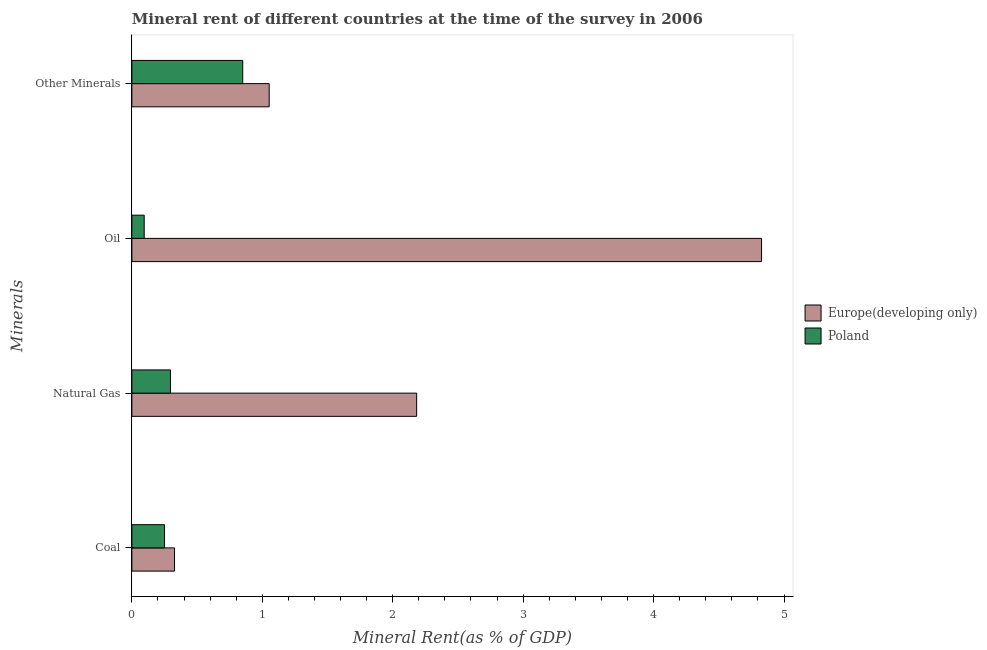How many different coloured bars are there?
Make the answer very short. 2. How many bars are there on the 3rd tick from the top?
Make the answer very short. 2. How many bars are there on the 1st tick from the bottom?
Ensure brevity in your answer.  2. What is the label of the 3rd group of bars from the top?
Your answer should be very brief. Natural Gas. What is the coal rent in Europe(developing only)?
Keep it short and to the point. 0.33. Across all countries, what is the maximum  rent of other minerals?
Keep it short and to the point. 1.05. Across all countries, what is the minimum natural gas rent?
Offer a very short reply. 0.3. In which country was the oil rent maximum?
Give a very brief answer. Europe(developing only). In which country was the oil rent minimum?
Offer a terse response. Poland. What is the total natural gas rent in the graph?
Your answer should be compact. 2.48. What is the difference between the natural gas rent in Europe(developing only) and that in Poland?
Make the answer very short. 1.89. What is the difference between the natural gas rent in Europe(developing only) and the  rent of other minerals in Poland?
Provide a short and direct response. 1.33. What is the average coal rent per country?
Provide a succinct answer. 0.29. What is the difference between the coal rent and  rent of other minerals in Poland?
Offer a very short reply. -0.6. What is the ratio of the natural gas rent in Europe(developing only) to that in Poland?
Give a very brief answer. 7.38. Is the difference between the natural gas rent in Europe(developing only) and Poland greater than the difference between the oil rent in Europe(developing only) and Poland?
Your response must be concise. No. What is the difference between the highest and the second highest oil rent?
Ensure brevity in your answer.  4.73. What is the difference between the highest and the lowest natural gas rent?
Provide a succinct answer. 1.89. In how many countries, is the oil rent greater than the average oil rent taken over all countries?
Keep it short and to the point. 1. Is the sum of the  rent of other minerals in Poland and Europe(developing only) greater than the maximum oil rent across all countries?
Offer a very short reply. No. Is it the case that in every country, the sum of the oil rent and  rent of other minerals is greater than the sum of natural gas rent and coal rent?
Your answer should be very brief. No. What does the 2nd bar from the top in Natural Gas represents?
Make the answer very short. Europe(developing only). Is it the case that in every country, the sum of the coal rent and natural gas rent is greater than the oil rent?
Give a very brief answer. No. How many bars are there?
Your response must be concise. 8. Are all the bars in the graph horizontal?
Offer a very short reply. Yes. How many countries are there in the graph?
Offer a very short reply. 2. What is the difference between two consecutive major ticks on the X-axis?
Offer a terse response. 1. Does the graph contain any zero values?
Give a very brief answer. No. Where does the legend appear in the graph?
Provide a short and direct response. Center right. What is the title of the graph?
Make the answer very short. Mineral rent of different countries at the time of the survey in 2006. What is the label or title of the X-axis?
Provide a succinct answer. Mineral Rent(as % of GDP). What is the label or title of the Y-axis?
Provide a short and direct response. Minerals. What is the Mineral Rent(as % of GDP) in Europe(developing only) in Coal?
Give a very brief answer. 0.33. What is the Mineral Rent(as % of GDP) of Poland in Coal?
Your answer should be very brief. 0.25. What is the Mineral Rent(as % of GDP) of Europe(developing only) in Natural Gas?
Your answer should be very brief. 2.18. What is the Mineral Rent(as % of GDP) of Poland in Natural Gas?
Your answer should be compact. 0.3. What is the Mineral Rent(as % of GDP) in Europe(developing only) in Oil?
Offer a terse response. 4.83. What is the Mineral Rent(as % of GDP) of Poland in Oil?
Make the answer very short. 0.09. What is the Mineral Rent(as % of GDP) in Europe(developing only) in Other Minerals?
Offer a very short reply. 1.05. What is the Mineral Rent(as % of GDP) in Poland in Other Minerals?
Offer a very short reply. 0.85. Across all Minerals, what is the maximum Mineral Rent(as % of GDP) in Europe(developing only)?
Provide a short and direct response. 4.83. Across all Minerals, what is the maximum Mineral Rent(as % of GDP) of Poland?
Give a very brief answer. 0.85. Across all Minerals, what is the minimum Mineral Rent(as % of GDP) of Europe(developing only)?
Your answer should be compact. 0.33. Across all Minerals, what is the minimum Mineral Rent(as % of GDP) of Poland?
Offer a very short reply. 0.09. What is the total Mineral Rent(as % of GDP) of Europe(developing only) in the graph?
Your response must be concise. 8.39. What is the total Mineral Rent(as % of GDP) of Poland in the graph?
Offer a terse response. 1.49. What is the difference between the Mineral Rent(as % of GDP) in Europe(developing only) in Coal and that in Natural Gas?
Keep it short and to the point. -1.86. What is the difference between the Mineral Rent(as % of GDP) of Poland in Coal and that in Natural Gas?
Offer a very short reply. -0.05. What is the difference between the Mineral Rent(as % of GDP) of Europe(developing only) in Coal and that in Oil?
Your response must be concise. -4.5. What is the difference between the Mineral Rent(as % of GDP) in Poland in Coal and that in Oil?
Offer a very short reply. 0.16. What is the difference between the Mineral Rent(as % of GDP) of Europe(developing only) in Coal and that in Other Minerals?
Your response must be concise. -0.73. What is the difference between the Mineral Rent(as % of GDP) of Poland in Coal and that in Other Minerals?
Provide a short and direct response. -0.6. What is the difference between the Mineral Rent(as % of GDP) in Europe(developing only) in Natural Gas and that in Oil?
Offer a very short reply. -2.64. What is the difference between the Mineral Rent(as % of GDP) in Poland in Natural Gas and that in Oil?
Your answer should be very brief. 0.2. What is the difference between the Mineral Rent(as % of GDP) in Europe(developing only) in Natural Gas and that in Other Minerals?
Make the answer very short. 1.13. What is the difference between the Mineral Rent(as % of GDP) in Poland in Natural Gas and that in Other Minerals?
Keep it short and to the point. -0.55. What is the difference between the Mineral Rent(as % of GDP) of Europe(developing only) in Oil and that in Other Minerals?
Keep it short and to the point. 3.78. What is the difference between the Mineral Rent(as % of GDP) of Poland in Oil and that in Other Minerals?
Your response must be concise. -0.76. What is the difference between the Mineral Rent(as % of GDP) of Europe(developing only) in Coal and the Mineral Rent(as % of GDP) of Poland in Natural Gas?
Provide a succinct answer. 0.03. What is the difference between the Mineral Rent(as % of GDP) in Europe(developing only) in Coal and the Mineral Rent(as % of GDP) in Poland in Oil?
Your response must be concise. 0.23. What is the difference between the Mineral Rent(as % of GDP) of Europe(developing only) in Coal and the Mineral Rent(as % of GDP) of Poland in Other Minerals?
Make the answer very short. -0.52. What is the difference between the Mineral Rent(as % of GDP) in Europe(developing only) in Natural Gas and the Mineral Rent(as % of GDP) in Poland in Oil?
Keep it short and to the point. 2.09. What is the difference between the Mineral Rent(as % of GDP) of Europe(developing only) in Natural Gas and the Mineral Rent(as % of GDP) of Poland in Other Minerals?
Your answer should be compact. 1.33. What is the difference between the Mineral Rent(as % of GDP) in Europe(developing only) in Oil and the Mineral Rent(as % of GDP) in Poland in Other Minerals?
Keep it short and to the point. 3.98. What is the average Mineral Rent(as % of GDP) in Europe(developing only) per Minerals?
Your answer should be very brief. 2.1. What is the average Mineral Rent(as % of GDP) of Poland per Minerals?
Give a very brief answer. 0.37. What is the difference between the Mineral Rent(as % of GDP) of Europe(developing only) and Mineral Rent(as % of GDP) of Poland in Coal?
Ensure brevity in your answer.  0.08. What is the difference between the Mineral Rent(as % of GDP) in Europe(developing only) and Mineral Rent(as % of GDP) in Poland in Natural Gas?
Provide a succinct answer. 1.89. What is the difference between the Mineral Rent(as % of GDP) in Europe(developing only) and Mineral Rent(as % of GDP) in Poland in Oil?
Give a very brief answer. 4.73. What is the difference between the Mineral Rent(as % of GDP) in Europe(developing only) and Mineral Rent(as % of GDP) in Poland in Other Minerals?
Give a very brief answer. 0.2. What is the ratio of the Mineral Rent(as % of GDP) in Europe(developing only) in Coal to that in Natural Gas?
Your response must be concise. 0.15. What is the ratio of the Mineral Rent(as % of GDP) in Poland in Coal to that in Natural Gas?
Make the answer very short. 0.85. What is the ratio of the Mineral Rent(as % of GDP) of Europe(developing only) in Coal to that in Oil?
Offer a terse response. 0.07. What is the ratio of the Mineral Rent(as % of GDP) of Poland in Coal to that in Oil?
Make the answer very short. 2.65. What is the ratio of the Mineral Rent(as % of GDP) of Europe(developing only) in Coal to that in Other Minerals?
Your response must be concise. 0.31. What is the ratio of the Mineral Rent(as % of GDP) in Poland in Coal to that in Other Minerals?
Provide a short and direct response. 0.29. What is the ratio of the Mineral Rent(as % of GDP) in Europe(developing only) in Natural Gas to that in Oil?
Offer a very short reply. 0.45. What is the ratio of the Mineral Rent(as % of GDP) of Poland in Natural Gas to that in Oil?
Ensure brevity in your answer.  3.13. What is the ratio of the Mineral Rent(as % of GDP) of Europe(developing only) in Natural Gas to that in Other Minerals?
Provide a short and direct response. 2.07. What is the ratio of the Mineral Rent(as % of GDP) of Poland in Natural Gas to that in Other Minerals?
Provide a succinct answer. 0.35. What is the ratio of the Mineral Rent(as % of GDP) of Europe(developing only) in Oil to that in Other Minerals?
Offer a very short reply. 4.59. What is the ratio of the Mineral Rent(as % of GDP) in Poland in Oil to that in Other Minerals?
Your response must be concise. 0.11. What is the difference between the highest and the second highest Mineral Rent(as % of GDP) in Europe(developing only)?
Your response must be concise. 2.64. What is the difference between the highest and the second highest Mineral Rent(as % of GDP) of Poland?
Your answer should be compact. 0.55. What is the difference between the highest and the lowest Mineral Rent(as % of GDP) of Europe(developing only)?
Ensure brevity in your answer.  4.5. What is the difference between the highest and the lowest Mineral Rent(as % of GDP) of Poland?
Your response must be concise. 0.76. 